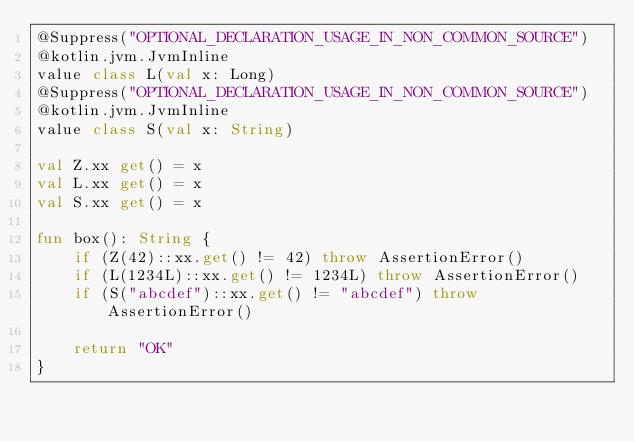Convert code to text. <code><loc_0><loc_0><loc_500><loc_500><_Kotlin_>@Suppress("OPTIONAL_DECLARATION_USAGE_IN_NON_COMMON_SOURCE")
@kotlin.jvm.JvmInline
value class L(val x: Long)
@Suppress("OPTIONAL_DECLARATION_USAGE_IN_NON_COMMON_SOURCE")
@kotlin.jvm.JvmInline
value class S(val x: String)

val Z.xx get() = x
val L.xx get() = x
val S.xx get() = x

fun box(): String {
    if (Z(42)::xx.get() != 42) throw AssertionError()
    if (L(1234L)::xx.get() != 1234L) throw AssertionError()
    if (S("abcdef")::xx.get() != "abcdef") throw AssertionError()

    return "OK"
}</code> 